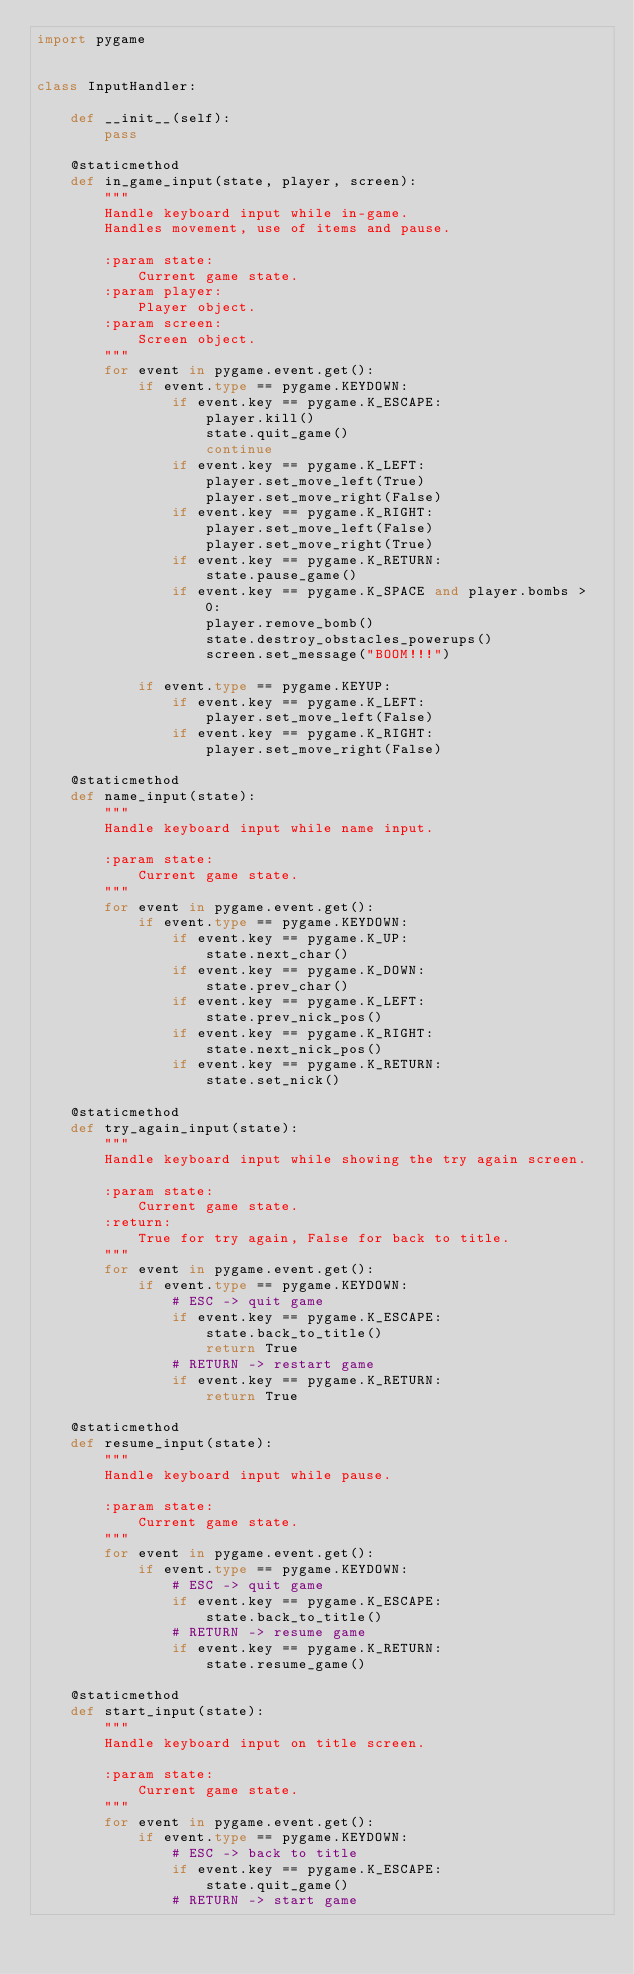<code> <loc_0><loc_0><loc_500><loc_500><_Python_>import pygame


class InputHandler:

    def __init__(self):
        pass

    @staticmethod
    def in_game_input(state, player, screen):
        """
        Handle keyboard input while in-game.
        Handles movement, use of items and pause.

        :param state:
            Current game state.
        :param player:
            Player object.
        :param screen:
            Screen object.
        """
        for event in pygame.event.get():
            if event.type == pygame.KEYDOWN:
                if event.key == pygame.K_ESCAPE:
                    player.kill()
                    state.quit_game()
                    continue
                if event.key == pygame.K_LEFT:
                    player.set_move_left(True)
                    player.set_move_right(False)
                if event.key == pygame.K_RIGHT:
                    player.set_move_left(False)
                    player.set_move_right(True)
                if event.key == pygame.K_RETURN:
                    state.pause_game()
                if event.key == pygame.K_SPACE and player.bombs > 0:
                    player.remove_bomb()
                    state.destroy_obstacles_powerups()
                    screen.set_message("BOOM!!!")

            if event.type == pygame.KEYUP:
                if event.key == pygame.K_LEFT:
                    player.set_move_left(False)
                if event.key == pygame.K_RIGHT:
                    player.set_move_right(False)

    @staticmethod
    def name_input(state):
        """
        Handle keyboard input while name input.

        :param state:
            Current game state.
        """
        for event in pygame.event.get():
            if event.type == pygame.KEYDOWN:
                if event.key == pygame.K_UP:
                    state.next_char()
                if event.key == pygame.K_DOWN:
                    state.prev_char()
                if event.key == pygame.K_LEFT:
                    state.prev_nick_pos()
                if event.key == pygame.K_RIGHT:
                    state.next_nick_pos()
                if event.key == pygame.K_RETURN:
                    state.set_nick()

    @staticmethod
    def try_again_input(state):
        """
        Handle keyboard input while showing the try again screen.

        :param state:
            Current game state.
        :return:
            True for try again, False for back to title.
        """
        for event in pygame.event.get():
            if event.type == pygame.KEYDOWN:
                # ESC -> quit game
                if event.key == pygame.K_ESCAPE:
                    state.back_to_title()
                    return True
                # RETURN -> restart game
                if event.key == pygame.K_RETURN:
                    return True

    @staticmethod
    def resume_input(state):
        """
        Handle keyboard input while pause.

        :param state:
            Current game state.
        """
        for event in pygame.event.get():
            if event.type == pygame.KEYDOWN:
                # ESC -> quit game
                if event.key == pygame.K_ESCAPE:
                    state.back_to_title()
                # RETURN -> resume game
                if event.key == pygame.K_RETURN:
                    state.resume_game()

    @staticmethod
    def start_input(state):
        """
        Handle keyboard input on title screen.

        :param state:
            Current game state.
        """
        for event in pygame.event.get():
            if event.type == pygame.KEYDOWN:
                # ESC -> back to title
                if event.key == pygame.K_ESCAPE:
                    state.quit_game()
                # RETURN -> start game</code> 